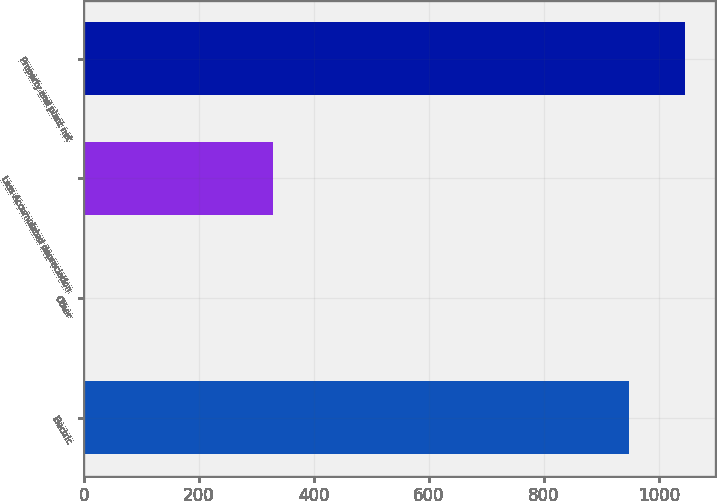Convert chart. <chart><loc_0><loc_0><loc_500><loc_500><bar_chart><fcel>Electric<fcel>Other<fcel>Less Accumulated depreciation<fcel>Property and plant net<nl><fcel>948<fcel>2<fcel>329<fcel>1045.8<nl></chart> 